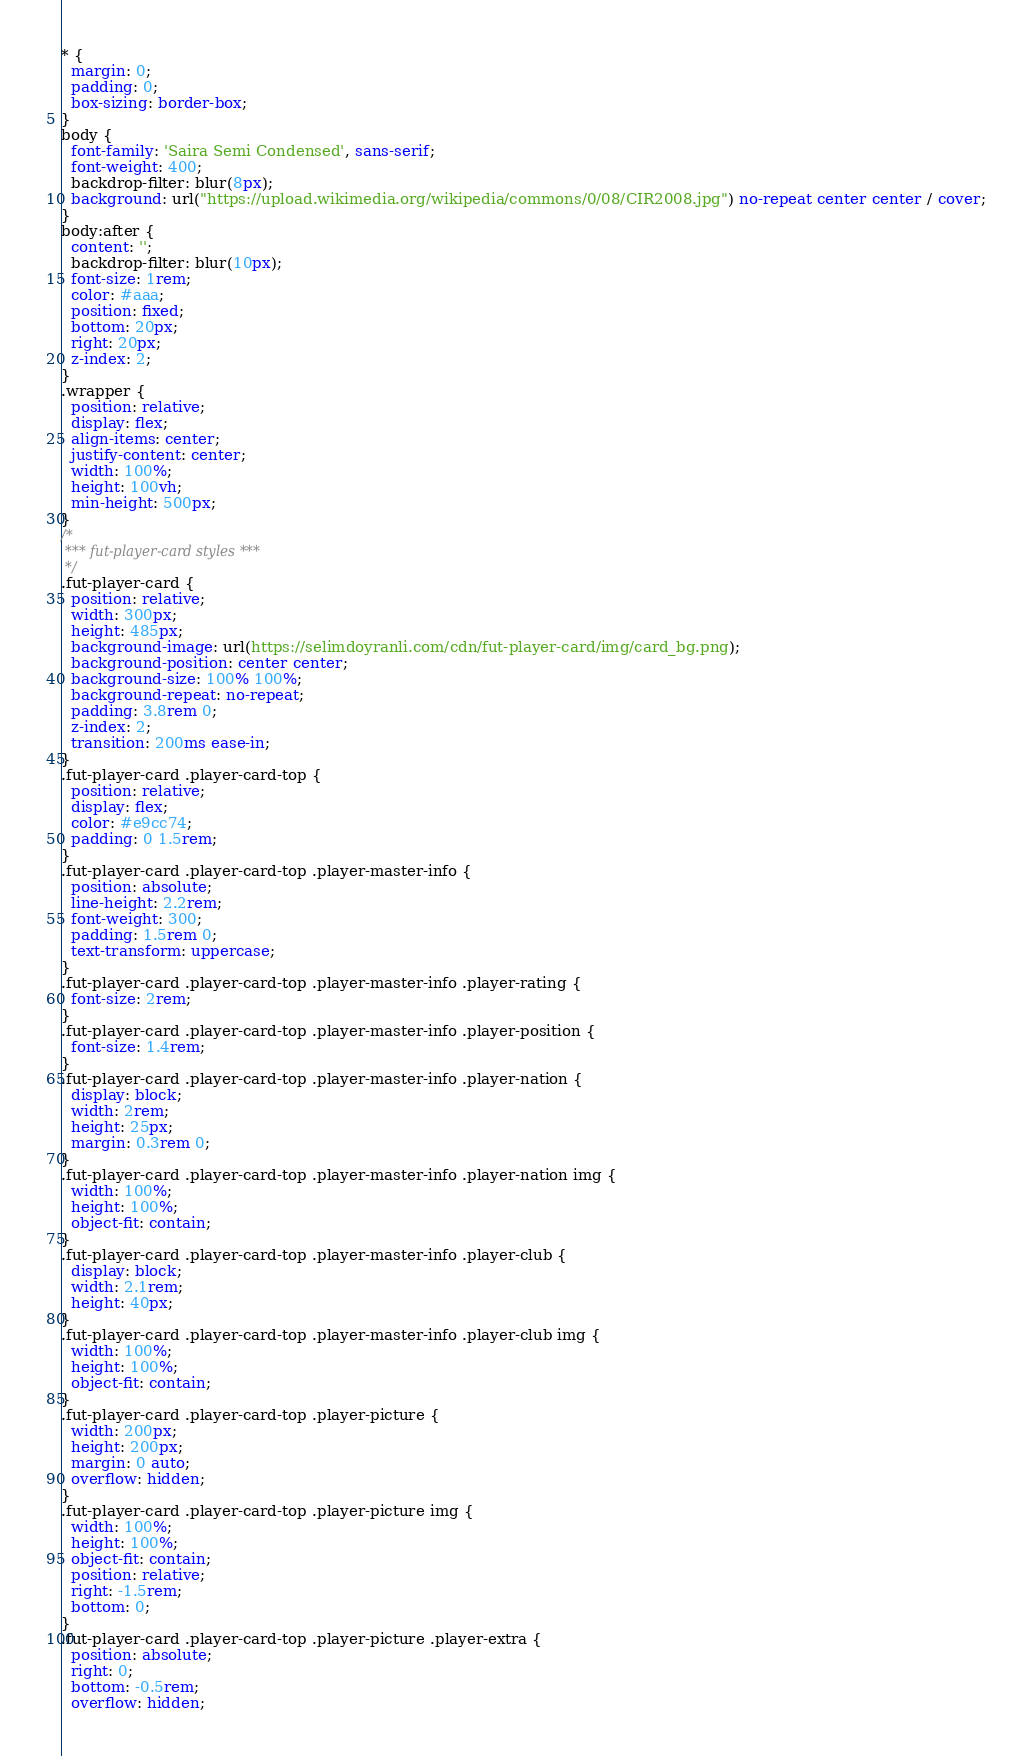<code> <loc_0><loc_0><loc_500><loc_500><_CSS_>* {
  margin: 0;
  padding: 0;
  box-sizing: border-box;
}
body {
  font-family: 'Saira Semi Condensed', sans-serif;
  font-weight: 400;
  backdrop-filter: blur(8px);
  background: url("https://upload.wikimedia.org/wikipedia/commons/0/08/CIR2008.jpg") no-repeat center center / cover;
}
body:after {
  content: '';
  backdrop-filter: blur(10px);
  font-size: 1rem;
  color: #aaa;
  position: fixed;
  bottom: 20px;
  right: 20px;
  z-index: 2;
}
.wrapper {
  position: relative;
  display: flex;
  align-items: center;
  justify-content: center;
  width: 100%;
  height: 100vh;
  min-height: 500px;
}
/*
 *** fut-player-card styles ***
 */
.fut-player-card {
  position: relative;
  width: 300px;
  height: 485px;
  background-image: url(https://selimdoyranli.com/cdn/fut-player-card/img/card_bg.png);
  background-position: center center;
  background-size: 100% 100%;
  background-repeat: no-repeat;
  padding: 3.8rem 0;
  z-index: 2;
  transition: 200ms ease-in;
}
.fut-player-card .player-card-top {
  position: relative;
  display: flex;
  color: #e9cc74;
  padding: 0 1.5rem;
}
.fut-player-card .player-card-top .player-master-info {
  position: absolute;
  line-height: 2.2rem;
  font-weight: 300;
  padding: 1.5rem 0;
  text-transform: uppercase;
}
.fut-player-card .player-card-top .player-master-info .player-rating {
  font-size: 2rem;
}
.fut-player-card .player-card-top .player-master-info .player-position {
  font-size: 1.4rem;
}
.fut-player-card .player-card-top .player-master-info .player-nation {
  display: block;
  width: 2rem;
  height: 25px;
  margin: 0.3rem 0;
}
.fut-player-card .player-card-top .player-master-info .player-nation img {
  width: 100%;
  height: 100%;
  object-fit: contain;
}
.fut-player-card .player-card-top .player-master-info .player-club {
  display: block;
  width: 2.1rem;
  height: 40px;
}
.fut-player-card .player-card-top .player-master-info .player-club img {
  width: 100%;
  height: 100%;
  object-fit: contain;
}
.fut-player-card .player-card-top .player-picture {
  width: 200px;
  height: 200px;
  margin: 0 auto;
  overflow: hidden;
}
.fut-player-card .player-card-top .player-picture img {
  width: 100%;
  height: 100%;
  object-fit: contain;
  position: relative;
  right: -1.5rem;
  bottom: 0;
}
.fut-player-card .player-card-top .player-picture .player-extra {
  position: absolute;
  right: 0;
  bottom: -0.5rem;
  overflow: hidden;</code> 